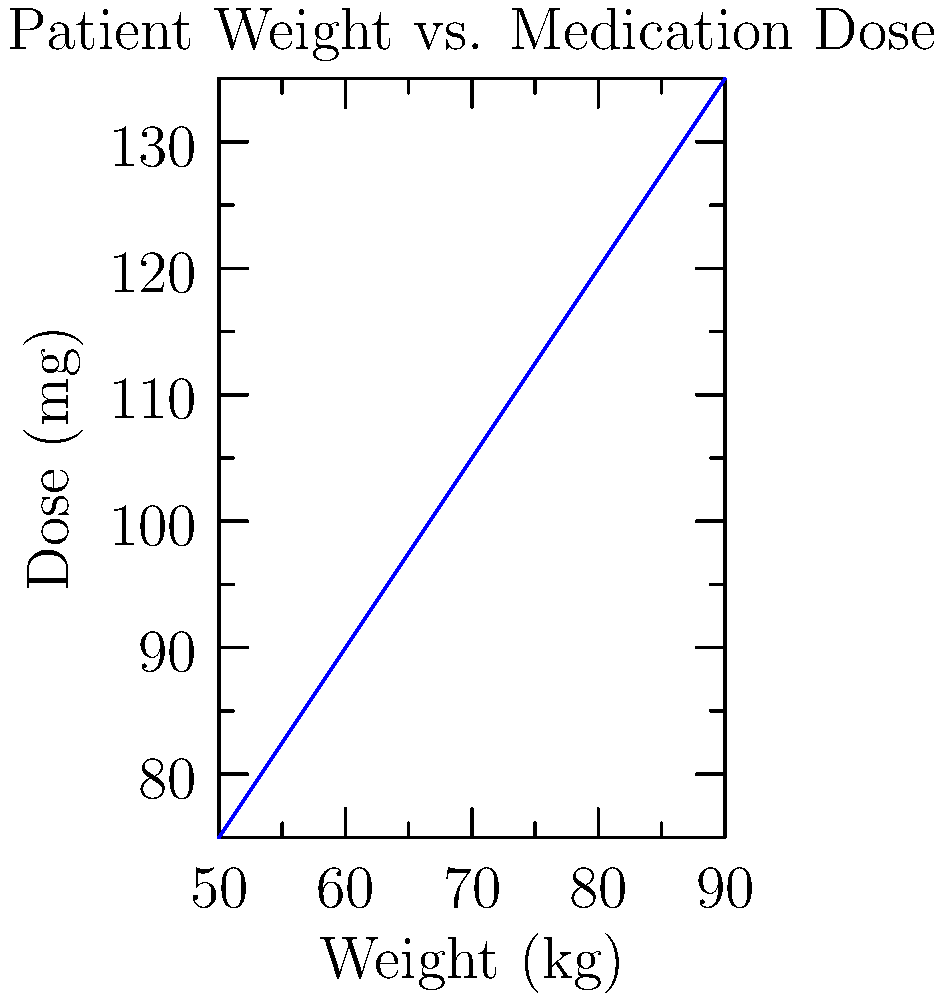A patient weighing 68 kg needs to be given a medication based on the dosage chart shown above. The dosage increases linearly with weight. Calculate the appropriate dose for this patient to the nearest 0.1 mg. To solve this problem, we need to follow these steps:

1) First, we need to determine the rate at which the dose increases with weight.
   We can see from the chart that for every 5 kg increase in weight, the dose increases by 7.5 mg.

2) We can calculate the rate of increase:
   Rate = $\frac{7.5 \text{ mg}}{5 \text{ kg}} = 1.5 \text{ mg/kg}$

3) Now, we need to find how much the patient's weight differs from the nearest lower weight on the chart.
   The nearest lower weight is 65 kg.
   Difference = $68 \text{ kg} - 65 \text{ kg} = 3 \text{ kg}$

4) We can calculate the additional dose needed for this 3 kg:
   Additional dose = $3 \text{ kg} \times 1.5 \text{ mg/kg} = 4.5 \text{ mg}$

5) The dose for 65 kg from the chart is 97.5 mg.
   So, the total dose for 68 kg would be:
   Total dose = $97.5 \text{ mg} + 4.5 \text{ mg} = 102 \text{ mg}$

Therefore, the appropriate dose for a 68 kg patient is 102.0 mg.
Answer: 102.0 mg 